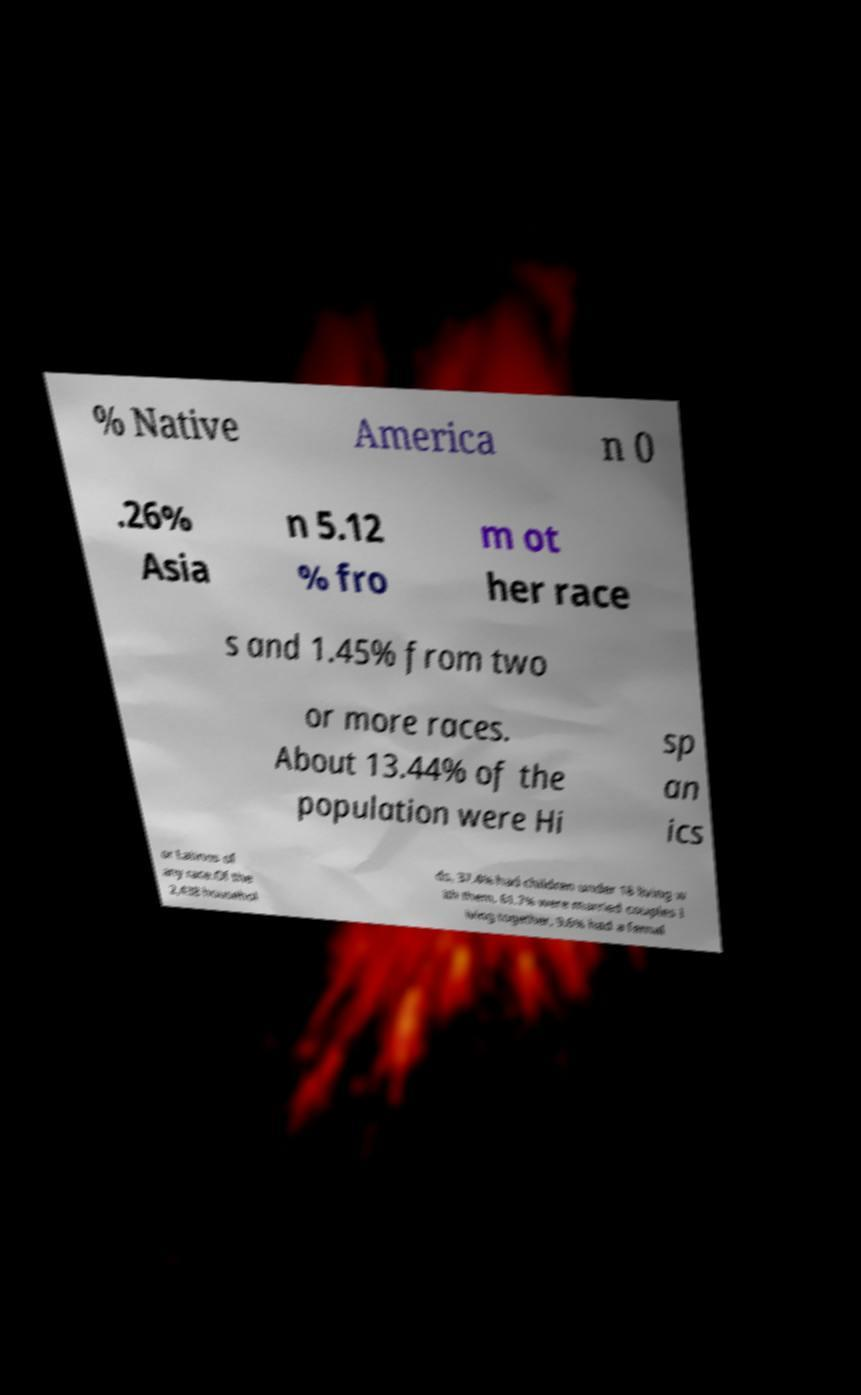Please read and relay the text visible in this image. What does it say? % Native America n 0 .26% Asia n 5.12 % fro m ot her race s and 1.45% from two or more races. About 13.44% of the population were Hi sp an ics or Latinos of any race.Of the 2,438 househol ds, 37.4% had children under 18 living w ith them, 61.7% were married couples l iving together, 9.6% had a femal 